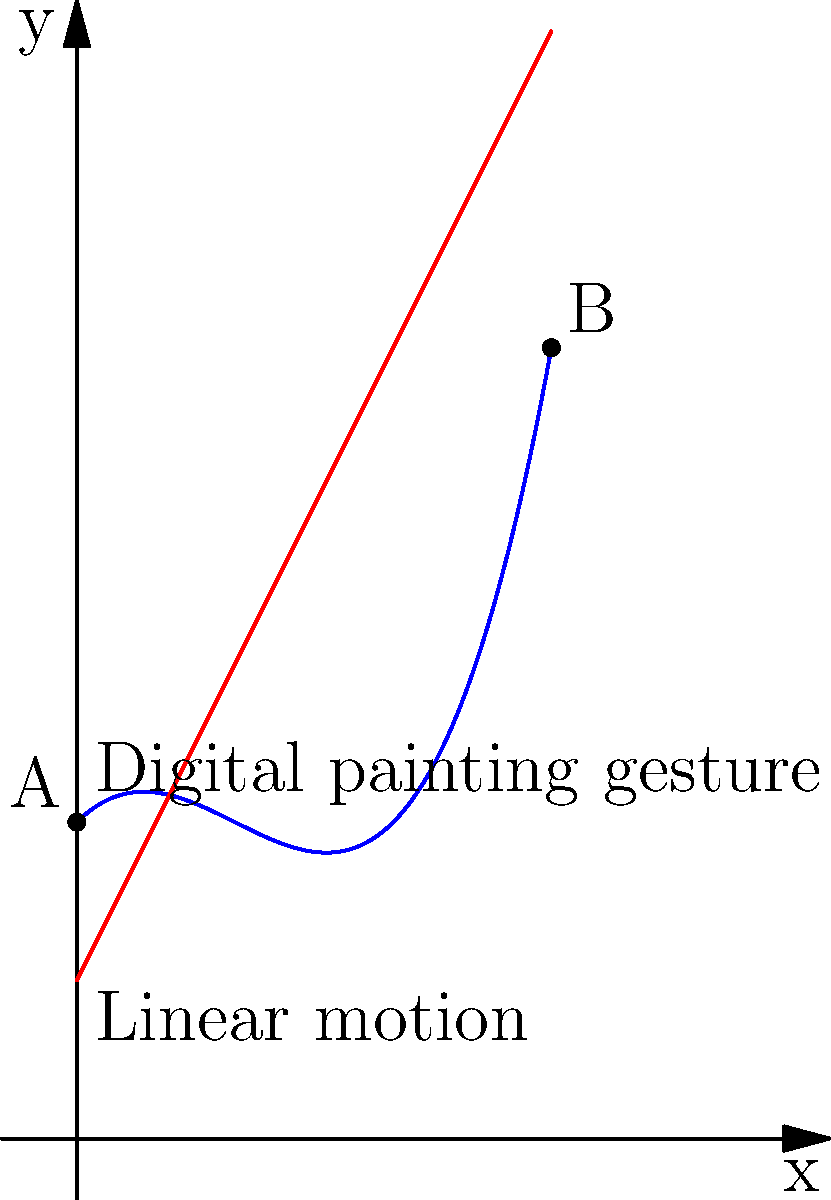In digital painting, artists often use stylus gestures that involve curved motions. The blue curve in the graph represents a typical curved gesture, while the red line represents a simple linear motion. How does the biomechanical force required for the curved gesture (blue) compare to the linear motion (red) in terms of muscle activation and energy expenditure? To answer this question, we need to analyze the biomechanical forces involved in both types of motions:

1. Linear motion (red line):
   - Represented by the equation $y = 2x + 1$
   - Constant velocity and direction
   - Requires consistent muscle activation

2. Curved gesture (blue curve):
   - Represented by the equation $y = 0.5x^3 - 1.5x^2 + x + 2$
   - Varying velocity and direction
   - Requires changing muscle activation patterns

Step-by-step analysis:

1. Acceleration: The curved gesture involves continuous changes in direction and speed, requiring more frequent adjustments in muscle activation. The linear motion has constant velocity, requiring less frequent adjustments.

2. Range of motion: The curved gesture covers a larger vertical range, potentially requiring greater wrist and finger flexion/extension.

3. Muscle group engagement: The curved gesture likely engages more diverse muscle groups due to its complex path, while the linear motion primarily uses muscles in a single plane of motion.

4. Force variability: The curved gesture requires varying forces to change direction and speed, leading to more complex motor control. The linear motion maintains a more consistent force throughout.

5. Energy expenditure: Due to the frequent changes in acceleration, muscle engagement, and force application, the curved gesture generally requires more energy than the linear motion.

6. Precision control: The curved gesture demands more precise control of hand and finger muscles to accurately follow the path, potentially leading to increased muscle tension and fatigue.

In conclusion, the biomechanical force required for the curved gesture (blue) is generally greater and more complex than the linear motion (red) in terms of muscle activation and energy expenditure.
Answer: Greater and more complex force required for curved gesture 